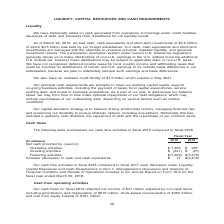According to Nortonlifelock's financial document, What does the table show? cash flow activities in fiscal 2019 compared to fiscal 2018. The document states: "The following table summarizes our cash flow activities in fiscal 2019 compared to fiscal 2018...." Also, What is date of the end of fiscal 2018? According to the financial document, March 30, 2018. The relevant text states: "ual Report on Form 10-K for the fiscal year ended March 30, 2018...." Also, What is the Net cash provided by operating activities in fiscal 2019? According to the financial document, $1,495 (in millions). The relevant text states: "ash provided by (used in): Operating activities $ 1,495 $ 957 Investing activities $ (241) $ (21) Financing activities $(1,209) $(3,475) Increase (decrease..." Also, can you calculate: What is the total Net cash provided by Operating activities for fiscal 2019 and 2018?  Based on the calculation: 1,495+957, the result is 2452 (in millions). This is based on the information: "ash provided by (used in): Operating activities $ 1,495 $ 957 Investing activities $ (241) $ (21) Financing activities $(1,209) $(3,475) Increase (decrease ided by (used in): Operating activities $ 1,..." The key data points involved are: 1,495, 957. Also, can you calculate: What is the average Net cash provided by for operating activities for fiscal 2019 and 2018? To answer this question, I need to perform calculations using the financial data. The calculation is: (1,495+957)/2, which equals 1226 (in millions). This is based on the information: "ash provided by (used in): Operating activities $ 1,495 $ 957 Investing activities $ (241) $ (21) Financing activities $(1,209) $(3,475) Increase (decrease ided by (used in): Operating activities $ 1,..." The key data points involved are: 1,495, 957. Also, can you calculate: What is the average Net cash used in for Financing activities for fiscal 2019 and 2018? To answer this question, I need to perform calculations using the financial data. The calculation is: (1,209+3,475)/2, which equals 2342 (in millions). This is based on the information: "activities $ (241) $ (21) Financing activities $(1,209) $(3,475) Increase (decrease) in cash and cash equivalents $ 17 $(2,473) es $ (241) $ (21) Financing activities $(1,209) $(3,475) Increase (decre..." The key data points involved are: 1,209, 3,475. 